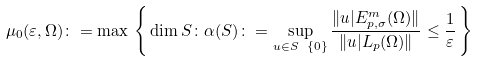<formula> <loc_0><loc_0><loc_500><loc_500>\mu _ { 0 } ( \varepsilon , \Omega ) \colon = \max \, \left \{ \, \dim S \colon \alpha ( S ) \colon = \sup _ { u \in S \ \{ 0 \} } \frac { \| u | E ^ { m } _ { p , \sigma } ( \Omega ) \| } { \| u | L _ { p } ( \Omega ) \| } \leq \frac { 1 } { \varepsilon } \, \right \}</formula> 